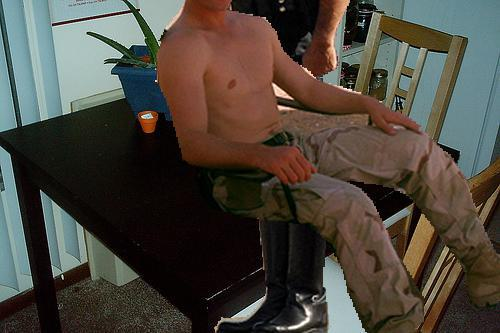Can you describe the room's atmosphere? The room gives off a homey and lived-in vibe, with natural light filtering in, creating a warm and welcoming atmosphere. There's a plant on the table, suggesting an appreciation for natural elements, and a candle, which might be used to create ambient lighting during the evenings. 